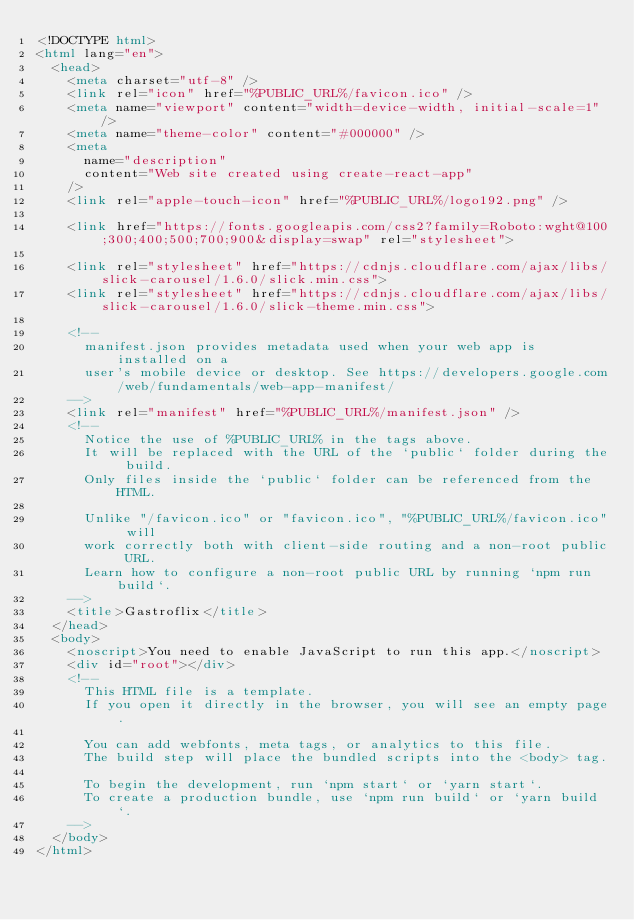Convert code to text. <code><loc_0><loc_0><loc_500><loc_500><_HTML_><!DOCTYPE html>
<html lang="en">
  <head>
    <meta charset="utf-8" />
    <link rel="icon" href="%PUBLIC_URL%/favicon.ico" />
    <meta name="viewport" content="width=device-width, initial-scale=1" />
    <meta name="theme-color" content="#000000" />
    <meta
      name="description"
      content="Web site created using create-react-app"
    />
    <link rel="apple-touch-icon" href="%PUBLIC_URL%/logo192.png" />
    
    <link href="https://fonts.googleapis.com/css2?family=Roboto:wght@100;300;400;500;700;900&display=swap" rel="stylesheet">
    
    <link rel="stylesheet" href="https://cdnjs.cloudflare.com/ajax/libs/slick-carousel/1.6.0/slick.min.css">
    <link rel="stylesheet" href="https://cdnjs.cloudflare.com/ajax/libs/slick-carousel/1.6.0/slick-theme.min.css">
    
    <!--
      manifest.json provides metadata used when your web app is installed on a
      user's mobile device or desktop. See https://developers.google.com/web/fundamentals/web-app-manifest/
    -->
    <link rel="manifest" href="%PUBLIC_URL%/manifest.json" />
    <!--
      Notice the use of %PUBLIC_URL% in the tags above.
      It will be replaced with the URL of the `public` folder during the build.
      Only files inside the `public` folder can be referenced from the HTML.

      Unlike "/favicon.ico" or "favicon.ico", "%PUBLIC_URL%/favicon.ico" will
      work correctly both with client-side routing and a non-root public URL.
      Learn how to configure a non-root public URL by running `npm run build`.
    -->
    <title>Gastroflix</title>
  </head>
  <body>
    <noscript>You need to enable JavaScript to run this app.</noscript>
    <div id="root"></div>
    <!--
      This HTML file is a template.
      If you open it directly in the browser, you will see an empty page.

      You can add webfonts, meta tags, or analytics to this file.
      The build step will place the bundled scripts into the <body> tag.

      To begin the development, run `npm start` or `yarn start`.
      To create a production bundle, use `npm run build` or `yarn build`.
    -->
  </body>
</html>
</code> 